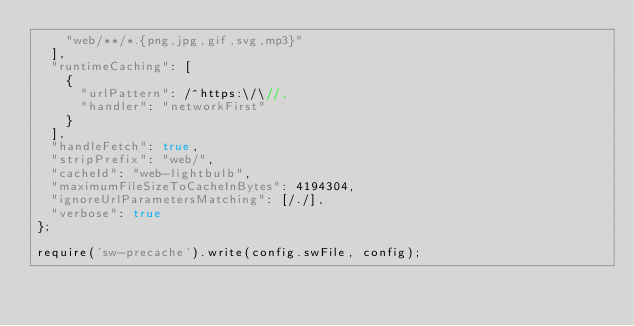<code> <loc_0><loc_0><loc_500><loc_500><_JavaScript_>    "web/**/*.{png,jpg,gif,svg,mp3}"
  ],
  "runtimeCaching": [
    {
      "urlPattern": /^https:\/\//,
      "handler": "networkFirst"
    }
  ],
  "handleFetch": true,
  "stripPrefix": "web/",
  "cacheId": "web-lightbulb",
  "maximumFileSizeToCacheInBytes": 4194304,
  "ignoreUrlParametersMatching": [/./],
  "verbose": true
};

require('sw-precache').write(config.swFile, config);
</code> 